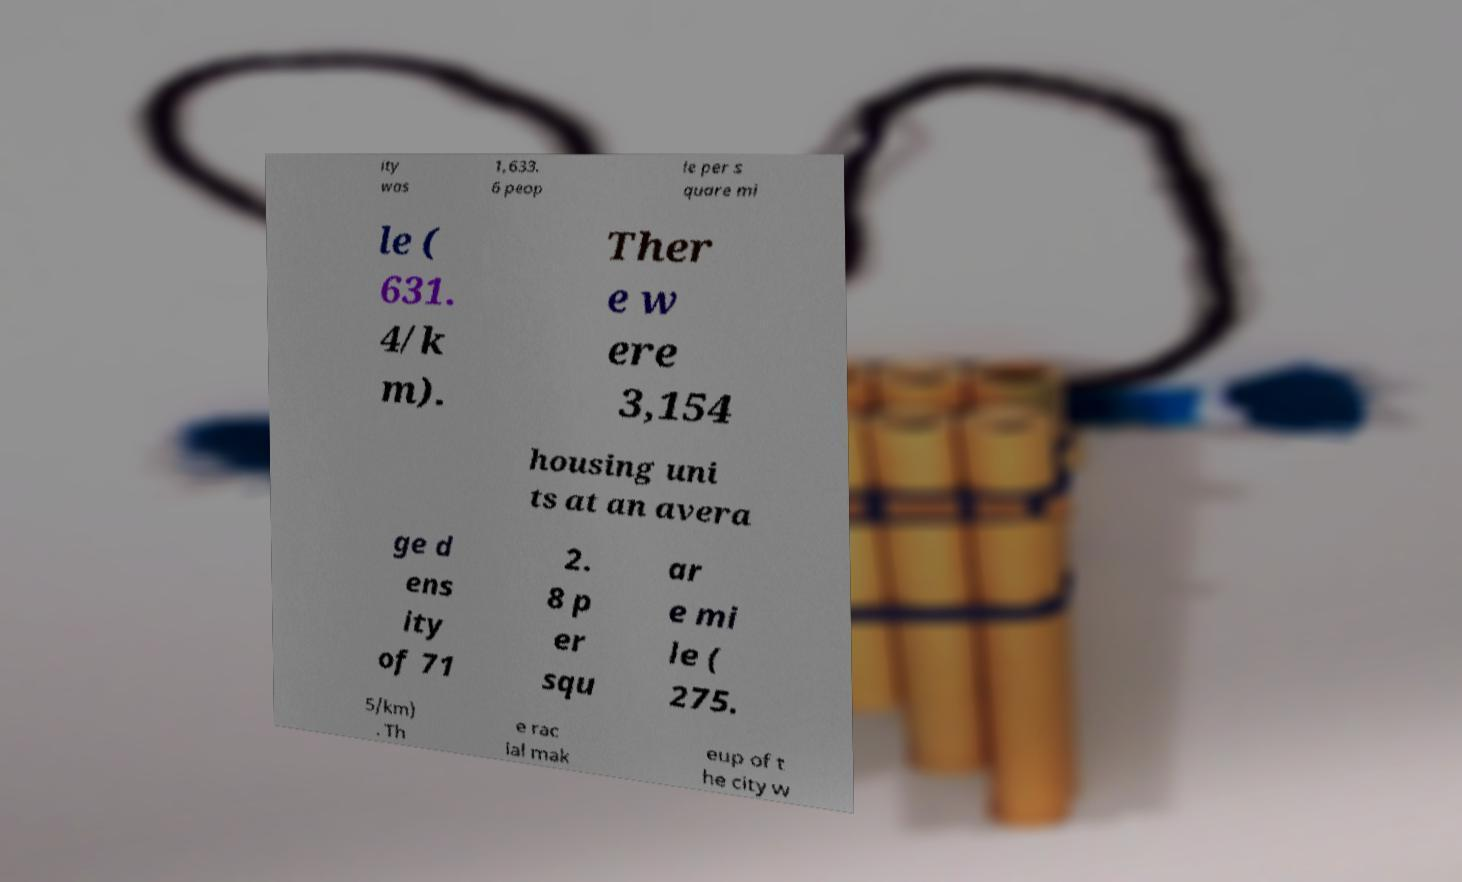For documentation purposes, I need the text within this image transcribed. Could you provide that? ity was 1,633. 6 peop le per s quare mi le ( 631. 4/k m). Ther e w ere 3,154 housing uni ts at an avera ge d ens ity of 71 2. 8 p er squ ar e mi le ( 275. 5/km) . Th e rac ial mak eup of t he city w 